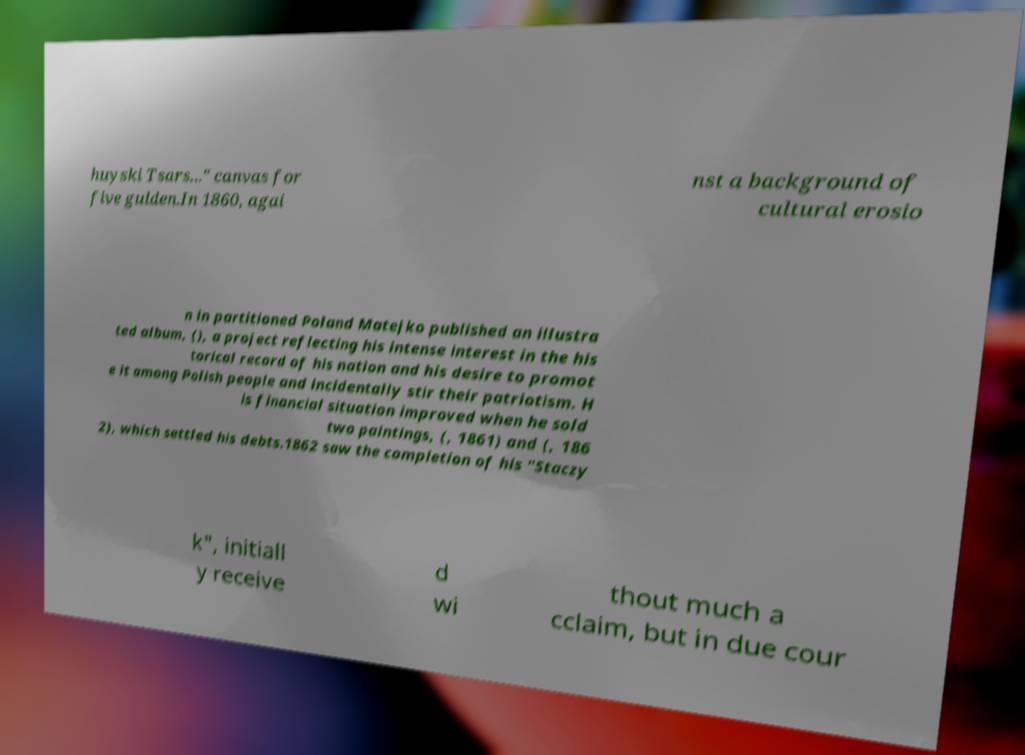There's text embedded in this image that I need extracted. Can you transcribe it verbatim? huyski Tsars..." canvas for five gulden.In 1860, agai nst a background of cultural erosio n in partitioned Poland Matejko published an illustra ted album, (), a project reflecting his intense interest in the his torical record of his nation and his desire to promot e it among Polish people and incidentally stir their patriotism. H is financial situation improved when he sold two paintings, (, 1861) and (, 186 2), which settled his debts.1862 saw the completion of his "Staczy k", initiall y receive d wi thout much a cclaim, but in due cour 